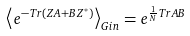Convert formula to latex. <formula><loc_0><loc_0><loc_500><loc_500>\left \langle e ^ { - T r ( { Z A } + { B Z ^ { * } } ) } \right \rangle _ { G i n } = e ^ { \frac { 1 } { N } T r { A B } }</formula> 